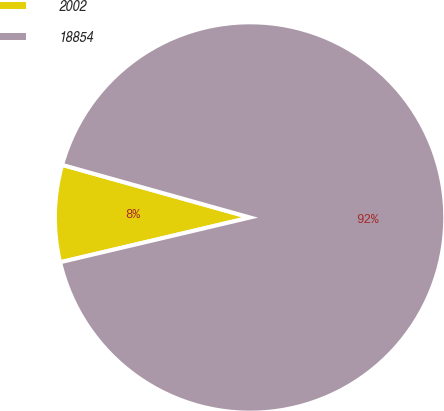Convert chart. <chart><loc_0><loc_0><loc_500><loc_500><pie_chart><fcel>2002<fcel>18854<nl><fcel>8.03%<fcel>91.97%<nl></chart> 